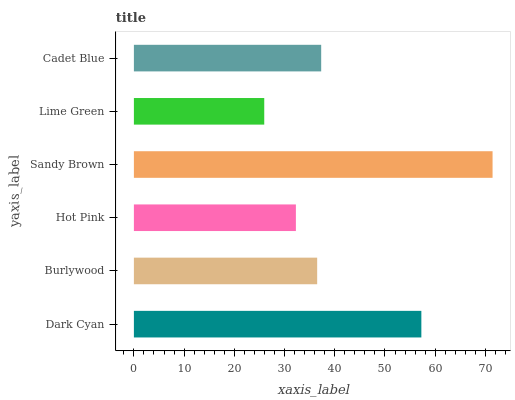Is Lime Green the minimum?
Answer yes or no. Yes. Is Sandy Brown the maximum?
Answer yes or no. Yes. Is Burlywood the minimum?
Answer yes or no. No. Is Burlywood the maximum?
Answer yes or no. No. Is Dark Cyan greater than Burlywood?
Answer yes or no. Yes. Is Burlywood less than Dark Cyan?
Answer yes or no. Yes. Is Burlywood greater than Dark Cyan?
Answer yes or no. No. Is Dark Cyan less than Burlywood?
Answer yes or no. No. Is Cadet Blue the high median?
Answer yes or no. Yes. Is Burlywood the low median?
Answer yes or no. Yes. Is Dark Cyan the high median?
Answer yes or no. No. Is Sandy Brown the low median?
Answer yes or no. No. 